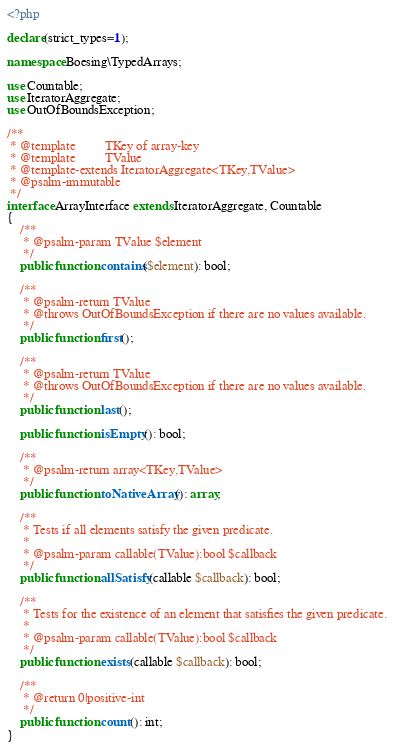<code> <loc_0><loc_0><loc_500><loc_500><_PHP_><?php

declare(strict_types=1);

namespace Boesing\TypedArrays;

use Countable;
use IteratorAggregate;
use OutOfBoundsException;

/**
 * @template         TKey of array-key
 * @template         TValue
 * @template-extends IteratorAggregate<TKey,TValue>
 * @psalm-immutable
 */
interface ArrayInterface extends IteratorAggregate, Countable
{
    /**
     * @psalm-param TValue $element
     */
    public function contains($element): bool;

    /**
     * @psalm-return TValue
     * @throws OutOfBoundsException if there are no values available.
     */
    public function first();

    /**
     * @psalm-return TValue
     * @throws OutOfBoundsException if there are no values available.
     */
    public function last();

    public function isEmpty(): bool;

    /**
     * @psalm-return array<TKey,TValue>
     */
    public function toNativeArray(): array;

    /**
     * Tests if all elements satisfy the given predicate.
     *
     * @psalm-param callable(TValue):bool $callback
     */
    public function allSatisfy(callable $callback): bool;

    /**
     * Tests for the existence of an element that satisfies the given predicate.
     *
     * @psalm-param callable(TValue):bool $callback
     */
    public function exists(callable $callback): bool;

    /**
     * @return 0|positive-int
     */
    public function count(): int;
}
</code> 